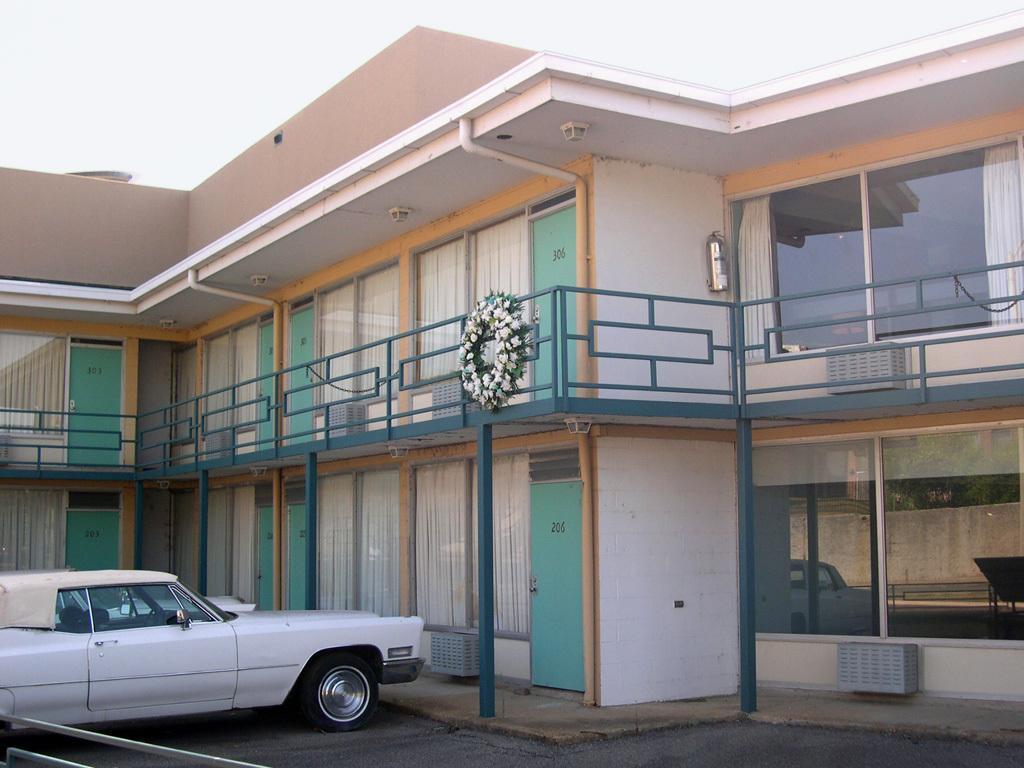How would you summarize this image in a sentence or two? In this image we can see a white color car, house, glass doors through which we can see curtains, garland, fire extinguisher, the reflection of the wall on the glass and the sky in the background. 